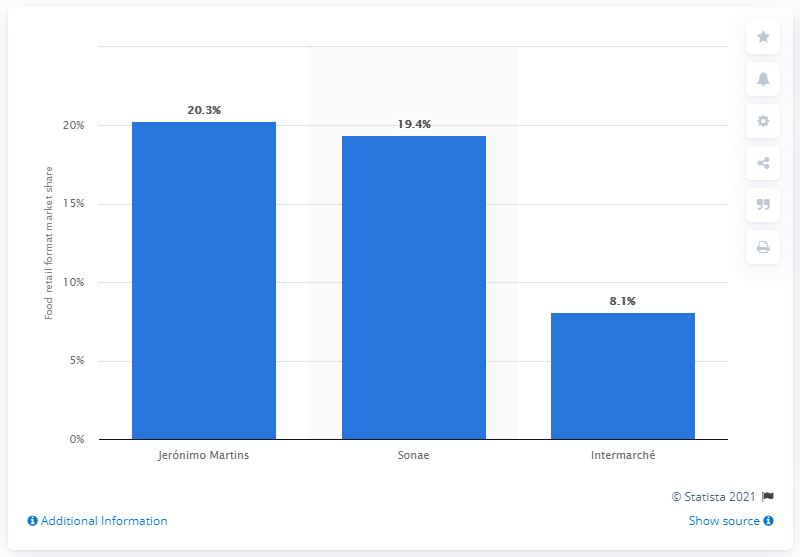Identify some key points in this picture. In 2013, Sonae was the second largest grocery store in Portugal. 